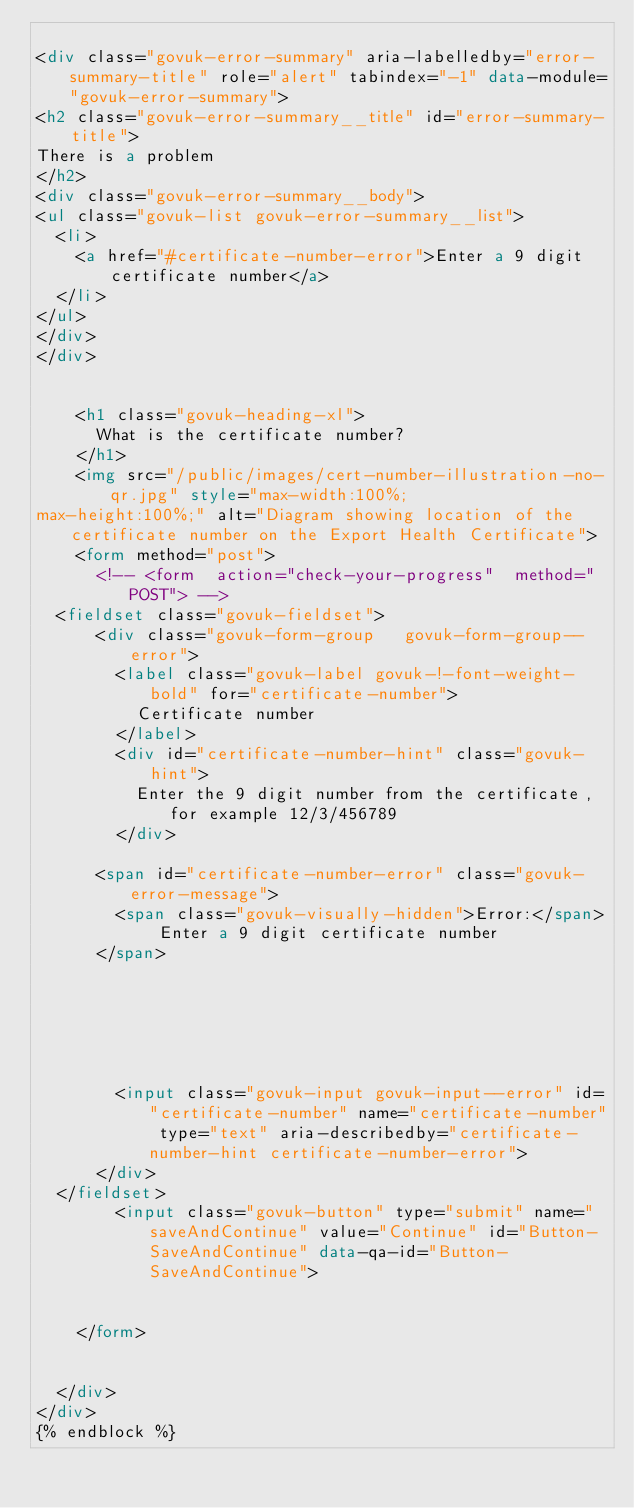<code> <loc_0><loc_0><loc_500><loc_500><_HTML_>
<div class="govuk-error-summary" aria-labelledby="error-summary-title" role="alert" tabindex="-1" data-module="govuk-error-summary">
<h2 class="govuk-error-summary__title" id="error-summary-title">
There is a problem
</h2>
<div class="govuk-error-summary__body">
<ul class="govuk-list govuk-error-summary__list">
  <li>
    <a href="#certificate-number-error">Enter a 9 digit certificate number</a>
  </li>
</ul>
</div>
</div>


    <h1 class="govuk-heading-xl">
      What is the certificate number?
    </h1>
    <img src="/public/images/cert-number-illustration-no-qr.jpg" style="max-width:100%;
max-height:100%;" alt="Diagram showing location of the certificate number on the Export Health Certificate">
    <form method="post">
      <!-- <form  action="check-your-progress"  method="POST"> -->
  <fieldset class="govuk-fieldset">
      <div class="govuk-form-group   govuk-form-group--error">
        <label class="govuk-label govuk-!-font-weight-bold" for="certificate-number">
          Certificate number
        </label>
        <div id="certificate-number-hint" class="govuk-hint">
          Enter the 9 digit number from the certificate, for example 12/3/456789
        </div>

      <span id="certificate-number-error" class="govuk-error-message">
        <span class="govuk-visually-hidden">Error:</span> Enter a 9 digit certificate number
      </span>






        <input class="govuk-input govuk-input--error" id="certificate-number" name="certificate-number" type="text" aria-describedby="certificate-number-hint certificate-number-error">
      </div>
  </fieldset>
        <input class="govuk-button" type="submit" name="saveAndContinue" value="Continue" id="Button-SaveAndContinue" data-qa-id="Button-SaveAndContinue">


    </form>


  </div>
</div>
{% endblock %}
</code> 